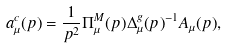<formula> <loc_0><loc_0><loc_500><loc_500>a ^ { c } _ { \mu } ( p ) = \frac { 1 } { p ^ { 2 } } \Pi ^ { M } _ { \mu } ( p ) \Delta ^ { g } _ { \mu } ( p ) ^ { - 1 } A _ { \mu } ( p ) ,</formula> 